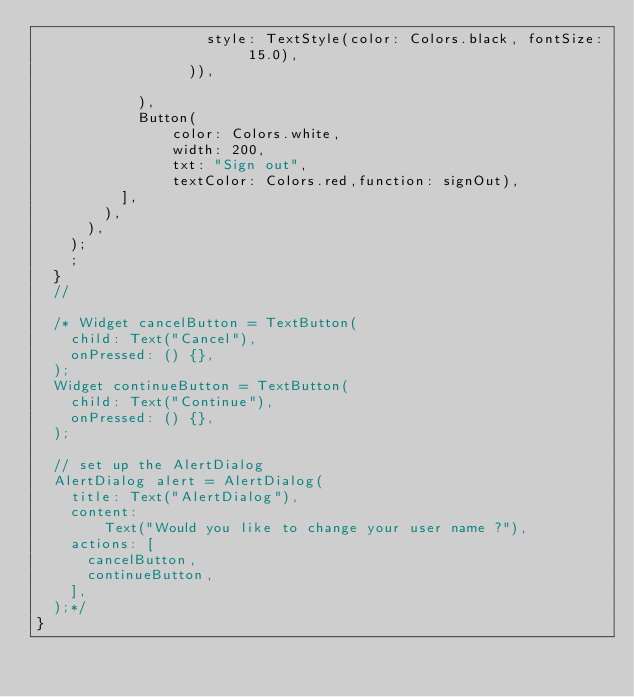Convert code to text. <code><loc_0><loc_0><loc_500><loc_500><_Dart_>                    style: TextStyle(color: Colors.black, fontSize: 15.0),
                  )),

            ),
            Button(
                color: Colors.white,
                width: 200,
                txt: "Sign out",
                textColor: Colors.red,function: signOut),
          ],
        ),
      ),
    );
    ;
  }
  //

  /* Widget cancelButton = TextButton(
    child: Text("Cancel"),
    onPressed: () {},
  );
  Widget continueButton = TextButton(
    child: Text("Continue"),
    onPressed: () {},
  );

  // set up the AlertDialog
  AlertDialog alert = AlertDialog(
    title: Text("AlertDialog"),
    content:
        Text("Would you like to change your user name ?"),
    actions: [
      cancelButton,
      continueButton,
    ],
  );*/
}
</code> 